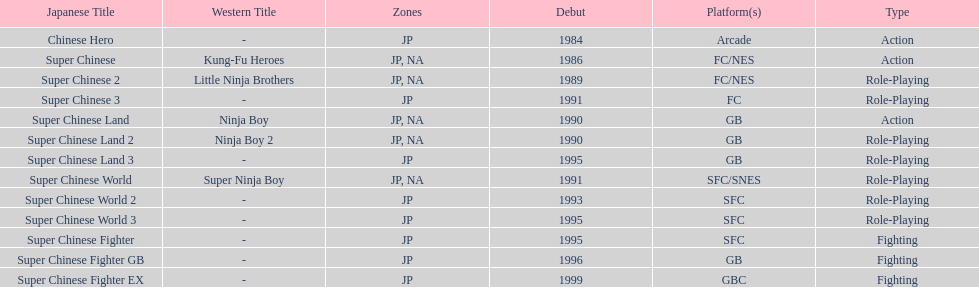How many action games were released in north america? 2. 